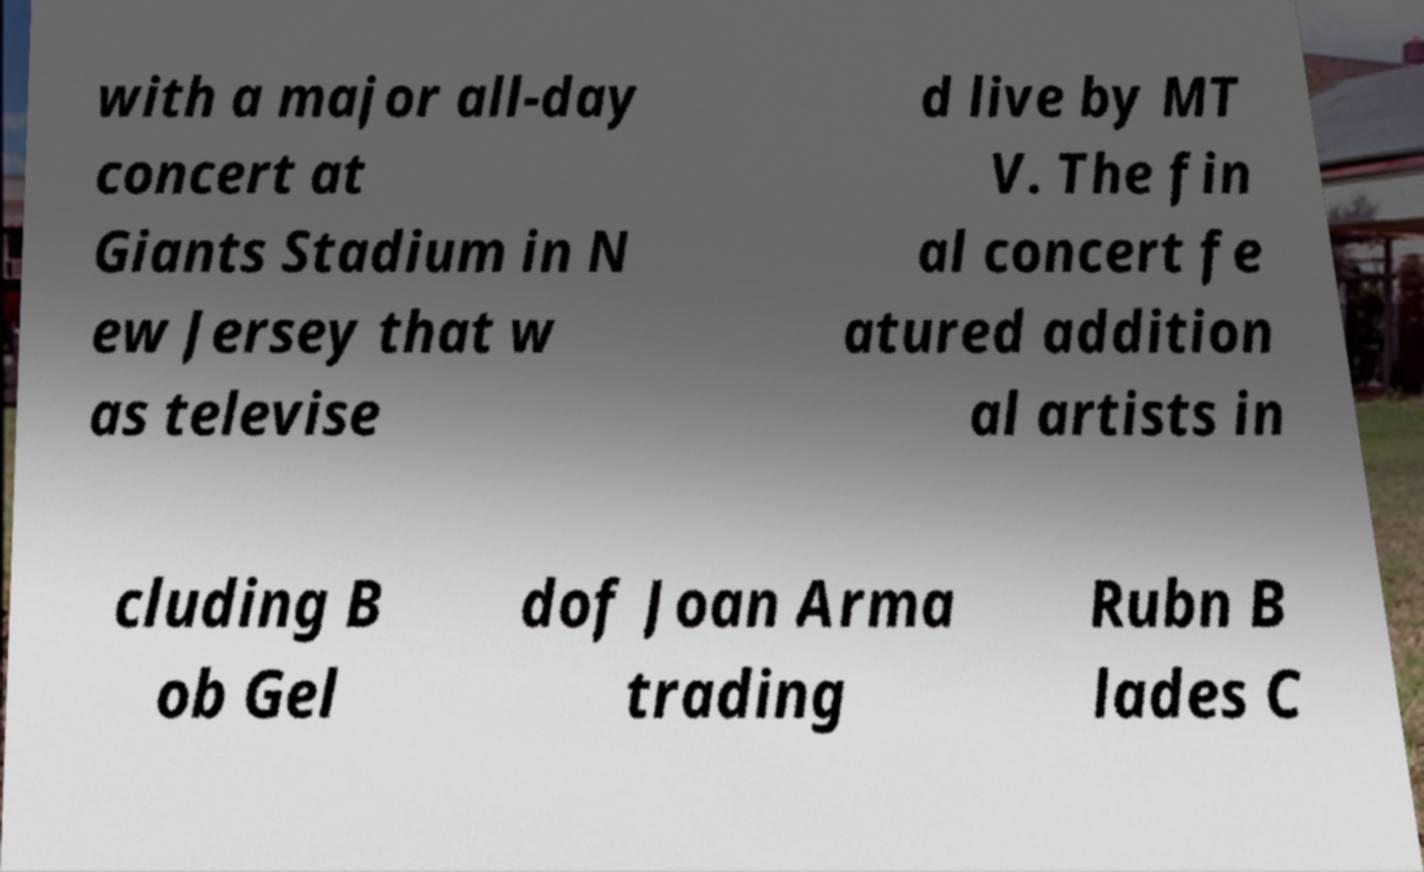Please identify and transcribe the text found in this image. with a major all-day concert at Giants Stadium in N ew Jersey that w as televise d live by MT V. The fin al concert fe atured addition al artists in cluding B ob Gel dof Joan Arma trading Rubn B lades C 